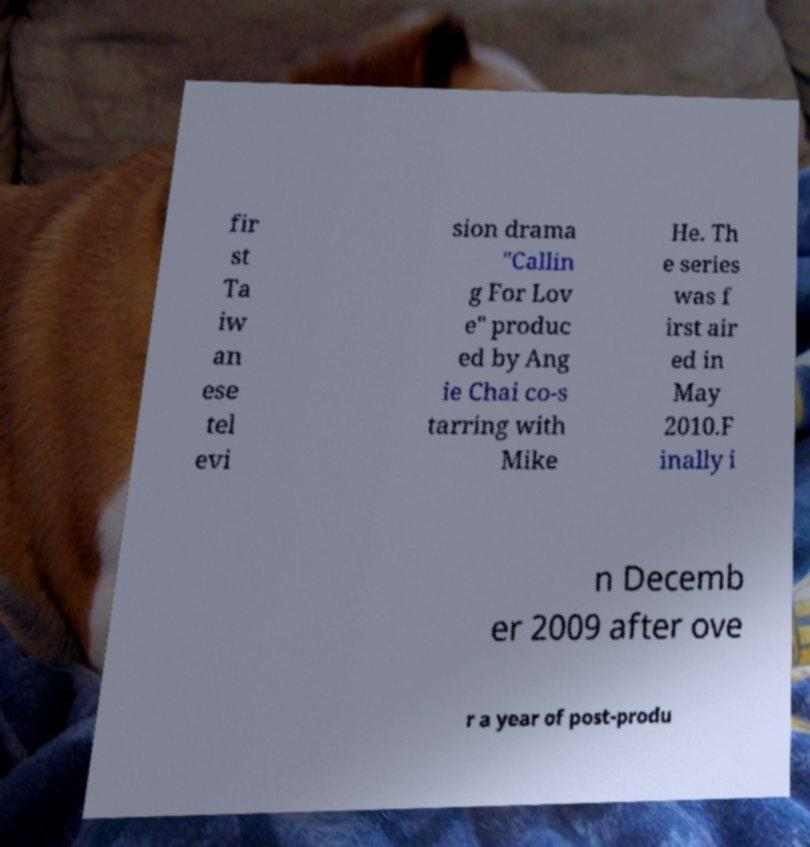Could you assist in decoding the text presented in this image and type it out clearly? fir st Ta iw an ese tel evi sion drama "Callin g For Lov e" produc ed by Ang ie Chai co-s tarring with Mike He. Th e series was f irst air ed in May 2010.F inally i n Decemb er 2009 after ove r a year of post-produ 